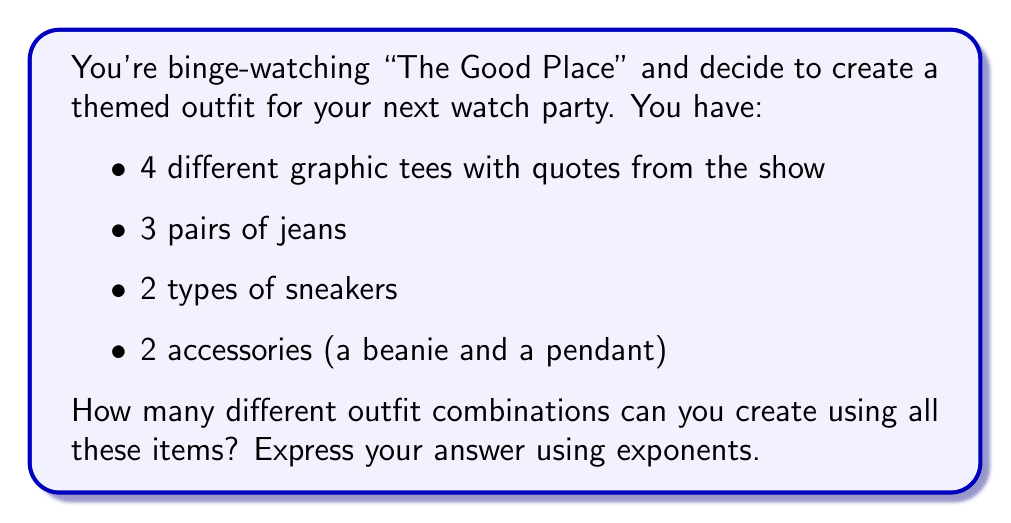Solve this math problem. Let's break this down step-by-step:

1) For each category of clothing, we have choices:
   - Tees: 4 choices
   - Jeans: 3 choices
   - Sneakers: 2 choices
   - Accessories: 2 choices

2) To find the total number of combinations, we use the multiplication principle. This states that if we have $m$ ways of doing something and $n$ ways of doing another thing, there are $m \times n$ ways of doing both.

3) In this case, we're choosing one item from each category. So we multiply the number of choices for each:

   $4 \times 3 \times 2 \times 2$

4) This can be rewritten using exponents:

   $4 \times 3 \times 2^2$

5) The final expression using exponents is:

   $4 \times 3 \times 2^2$

6) To calculate:
   $4 \times 3 = 12$
   $2^2 = 4$
   $12 \times 4 = 48$

So, there are 48 possible outfit combinations.
Answer: $4 \times 3 \times 2^2 = 48$ combinations 